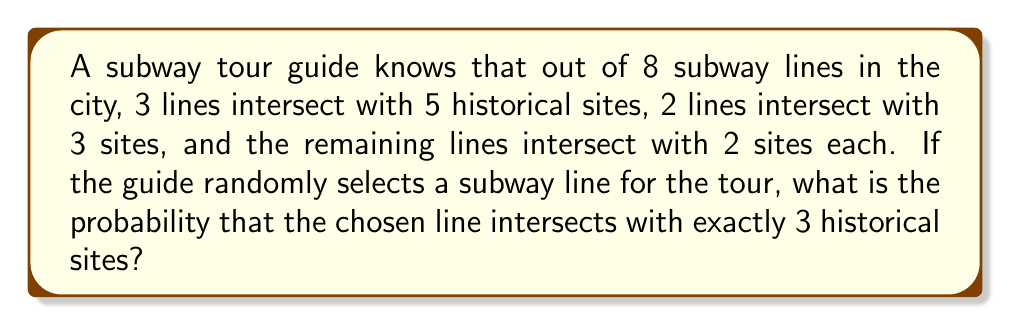Help me with this question. Let's approach this step-by-step:

1) First, let's identify the total number of subway lines and how many intersect with each number of historical sites:
   - Total subway lines: 8
   - Lines intersecting with 5 sites: 3
   - Lines intersecting with 3 sites: 2
   - Lines intersecting with 2 sites: 3 (the remaining lines)

2) We're interested in the probability of selecting a line that intersects with exactly 3 sites.

3) The probability is calculated by dividing the number of favorable outcomes by the total number of possible outcomes:

   $$P(\text{3 sites}) = \frac{\text{Number of lines intersecting with 3 sites}}{\text{Total number of lines}}$$

4) We know there are 2 lines that intersect with 3 sites, and there are 8 lines in total.

5) Therefore, the probability is:

   $$P(\text{3 sites}) = \frac{2}{8} = \frac{1}{4} = 0.25$$

This means there's a 25% chance of randomly selecting a subway line that intersects with exactly 3 historical sites.
Answer: $\frac{1}{4}$ or 0.25 or 25% 